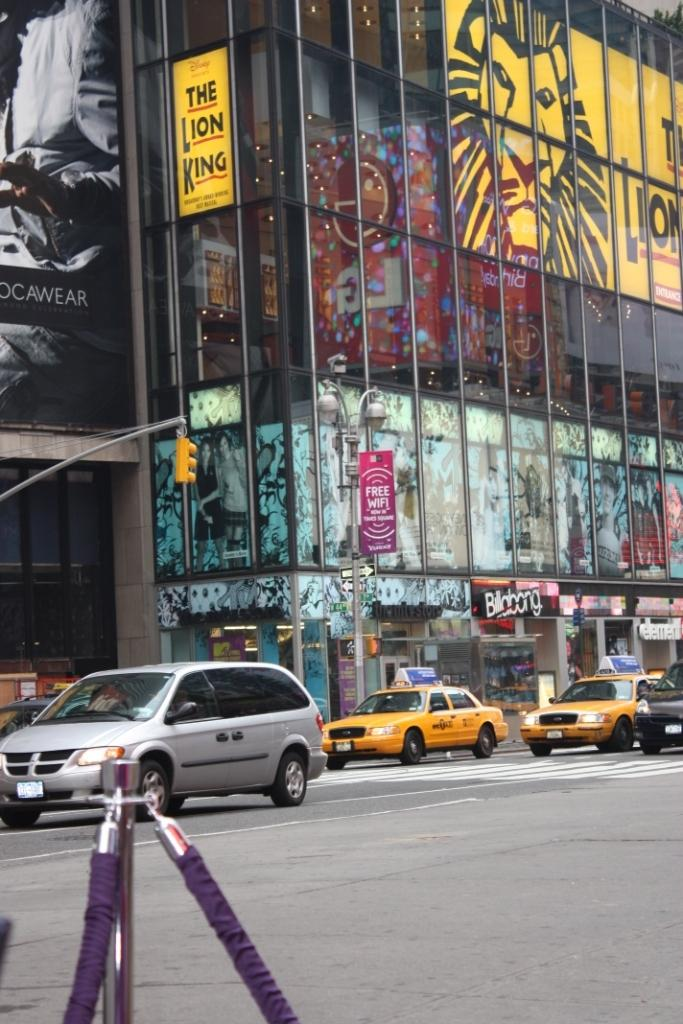<image>
Share a concise interpretation of the image provided. The Lion King is being advertised on a large city building. 